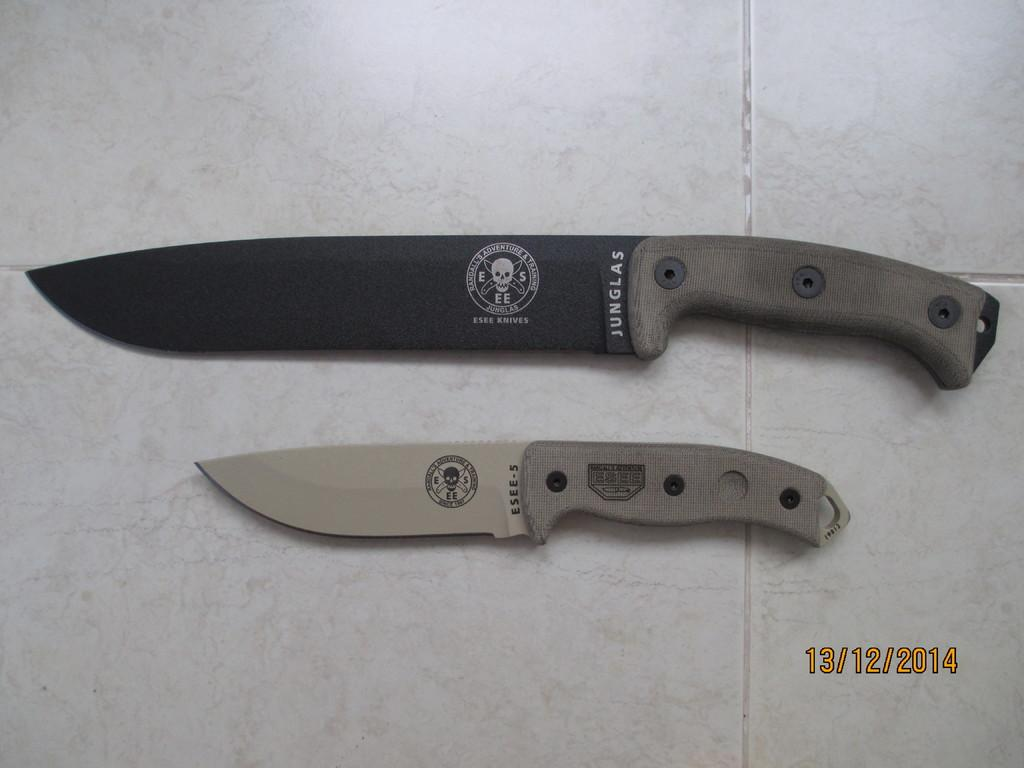<image>
Present a compact description of the photo's key features. A large and a small knife, the larger being made by Junglas, lie side by side. 